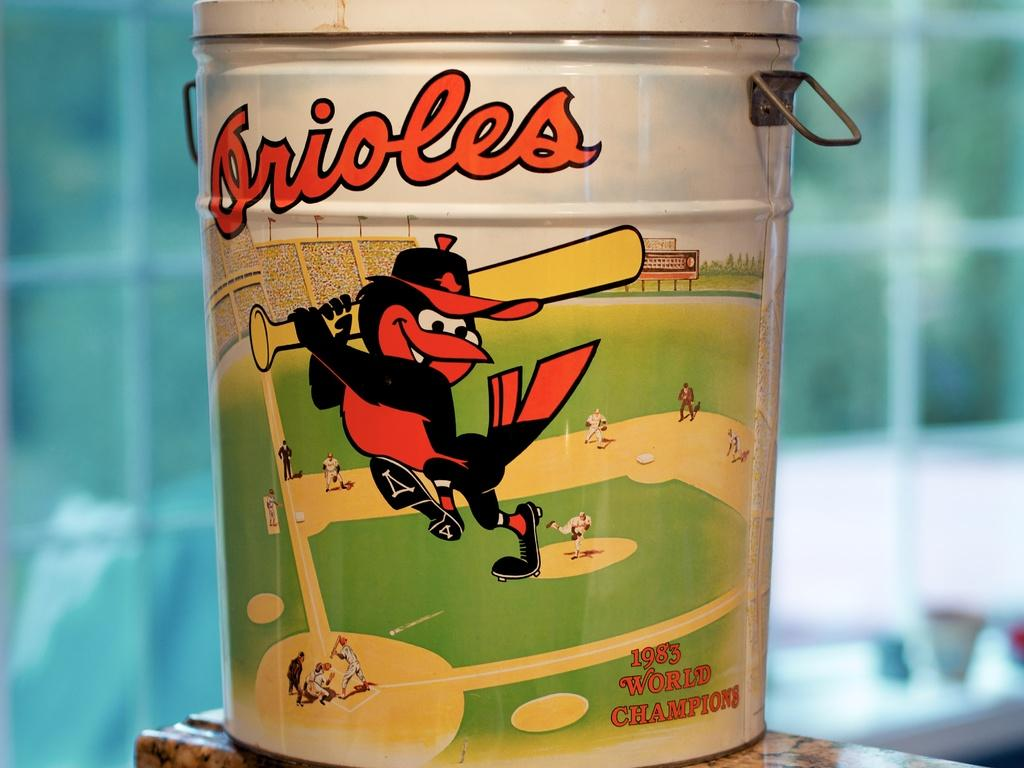<image>
Create a compact narrative representing the image presented. A covered tin has the Orioles mascot on it. 